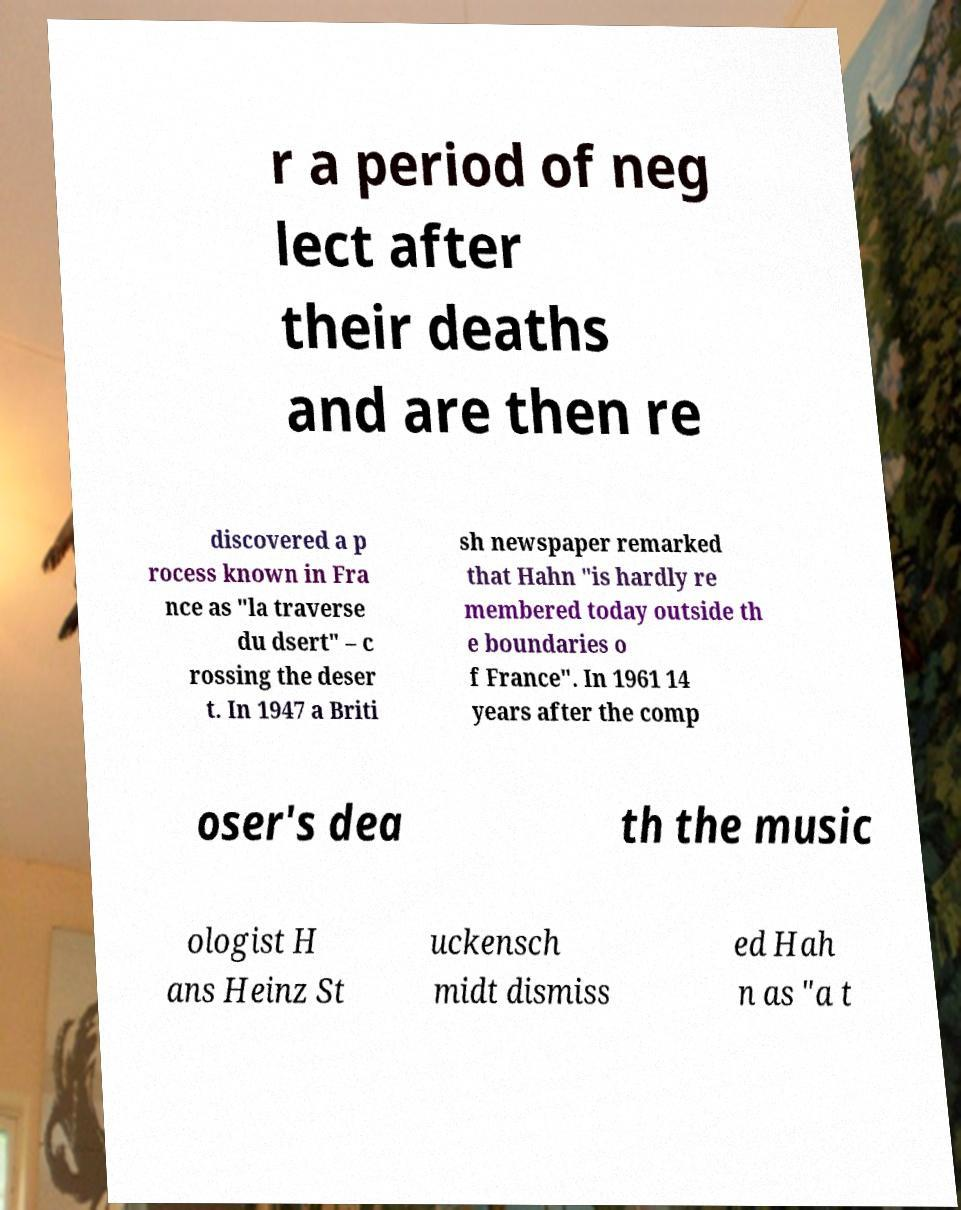Could you extract and type out the text from this image? r a period of neg lect after their deaths and are then re discovered a p rocess known in Fra nce as "la traverse du dsert" – c rossing the deser t. In 1947 a Briti sh newspaper remarked that Hahn "is hardly re membered today outside th e boundaries o f France". In 1961 14 years after the comp oser's dea th the music ologist H ans Heinz St uckensch midt dismiss ed Hah n as "a t 